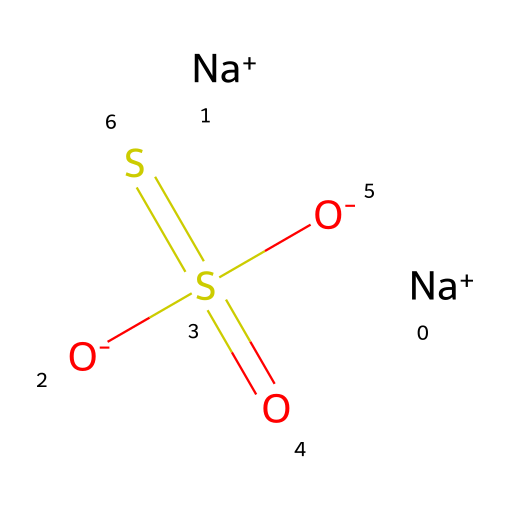What is the name of this chemical compound? The SMILES representation indicates that this compound consists of sodium, sulfur, and oxygen, and, combined with known information, it is identified as sodium thiosulfate.
Answer: sodium thiosulfate How many sodium (Na) atoms are in the structure? The SMILES representation contains two instances of [Na+], indicating two sodium atoms are present in the compound.
Answer: 2 How many sulfur (S) atoms are present? The SMILES notation shows S(=O)([O-])=S, which indicates there are two sulfur atoms in the structure, one as part of thiosulfate and the other being the sulfur in the SO2 part.
Answer: 2 What is the total number of oxygen (O) atoms in the compound? In the SMILES, there are four oxygen atoms shown: two in the thiosulfate part (from S(=O)([O-])) and two from Na+ and O-. Thus, the total is four.
Answer: 4 Is sodium thiosulfate an ionic compound? The presence of sodium ions ([Na+]) and the negatively charged thiosulfate ion indicate that the compound forms ionic bonds, characteristic of ionic compounds.
Answer: yes What role did sodium thiosulfate play in early photography? Sodium thiosulfate was used as a fixer, a chemical that stabilizes the image by removing unreacted silver halides in early photographic processes.
Answer: fixer How many bonds are present in the molecular structure? Analyzing the structure: there are two S=O double bonds and one S-S bond, giving a total of four bonds.
Answer: 4 